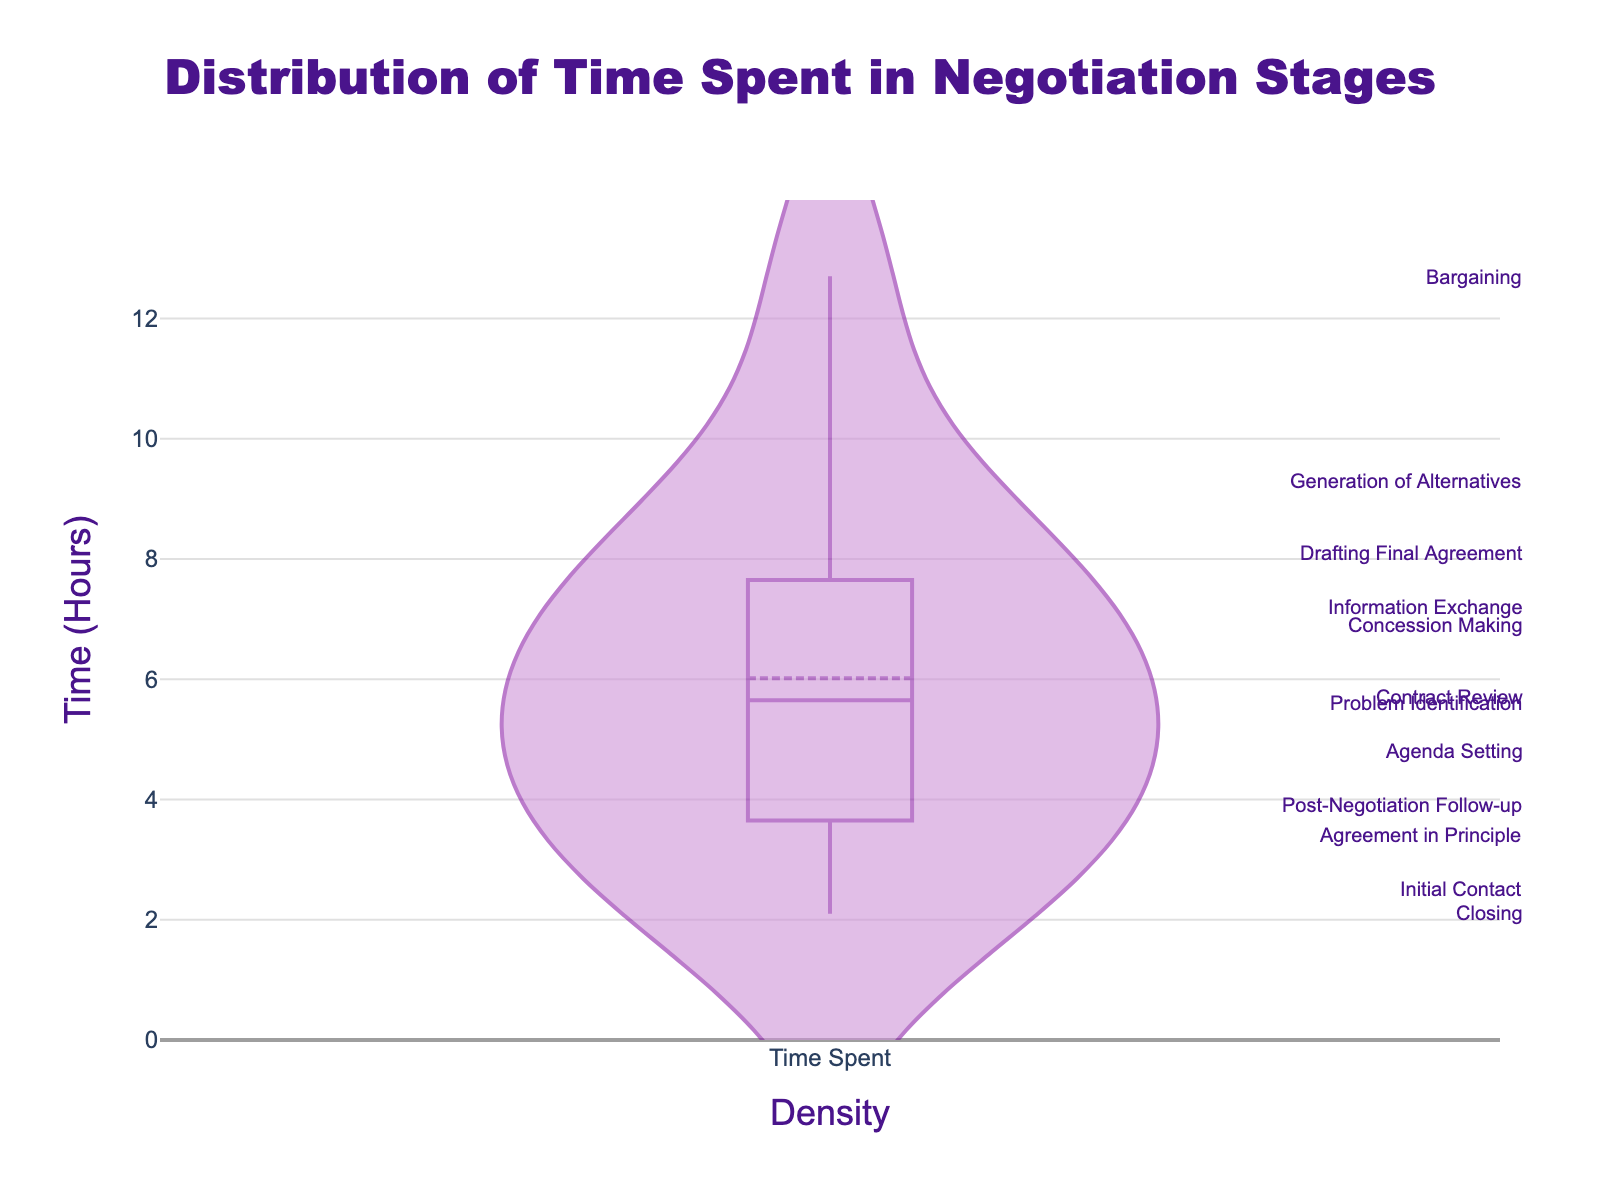What is the title of the figure? The title is usually displayed at the top of the figure to provide an overview of the content. Reading the title helps understand the overall context of the plot.
Answer: Distribution of Time Spent in Negotiation Stages What is the highest value on the y-axis? The highest value on the y-axis shows the maximum time spent on a stage in hours. This can be identified by looking at the topmost value on the y-axis scale.
Answer: 14 What is the mean time spent on negotiation stages? The mean time spent can be identified using the line on the density plot indicating the mean. This line is usually marked differently or specified in the legend.
Answer: It's visible via a line in the plot, around 6.3 hours Which stage takes the longest time? The longest time can be found by looking for the highest point on the y-axis and locating the corresponding stage annotation near it.
Answer: Bargaining How many stages take less than 4 hours? To determine this, count the stages whose time values are below the 4-hour mark on the y-axis. Markers or annotations help identify the specific stages.
Answer: Four stages (Initial Contact, Agreement in Principle, Closing, Post-Negotiation Follow-up) Which stage takes roughly twice as much time as 'Initial Contact'? Find the time duration of 'Initial Contact' and look for another stage with approximately twice this value.
Answer: Agenda Setting What is the average time spent on the stages 'Bargaining' and 'Drafting Final Agreement'? Add the time spent on 'Bargaining' and 'Drafting Final Agreement' and divide by 2 to find the average. Bargaining: 12.7 hours, Drafting Final Agreement: 8.1 hours. (12.7 + 8.1) / 2 = 10.4
Answer: 10.4 hours Does 'Concession Making' take more or less time than 'Contract Review'? Compare the time values of 'Concession Making' and 'Contract Review' to see which is higher.
Answer: Less (6.9 hours < 5.7 hours) What is the range of time spent on negotiation stages? The range is calculated by subtracting the shortest time from the longest time. Maximum time: Bargaining (12.7 hours), Minimum time: Closing (2.1 hours). 12.7 - 2.1 = 10.6
Answer: 10.6 hours Which stage shows a significant drop in time from 'Generation of Alternatives'? Review the stages and identify which next stage after 'Generation of Alternatives' has a noticeably lower time value. 'Generation of Alternatives' has 9.3 hours, and 'Concession Making' has 6.9 hours. 9.3 - 6.9 = 2.4 hours drop
Answer: Concession Making 